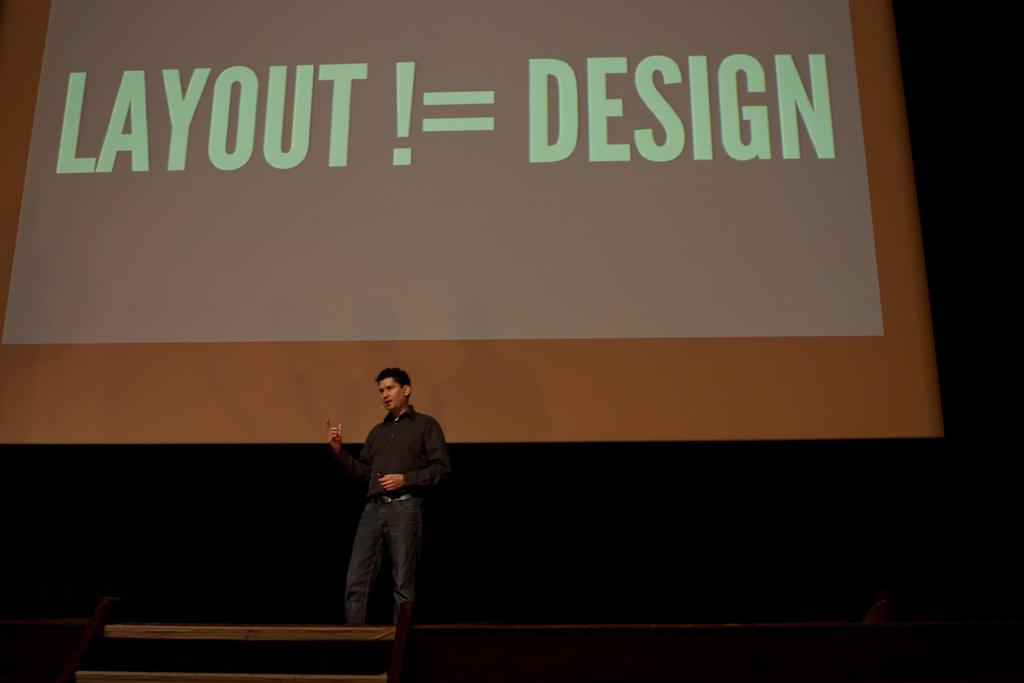What is the person in the image doing? The person is standing on the stage and talking. What can be seen behind the person on the stage? There is a screen at the back of the stage. What is displayed on the screen? There is text on the screen. What type of humor can be seen in the image? There is no humor present in the image; it features a person standing on a stage and a screen with text. How many balloons are visible in the image? There are no balloons present in the image. 